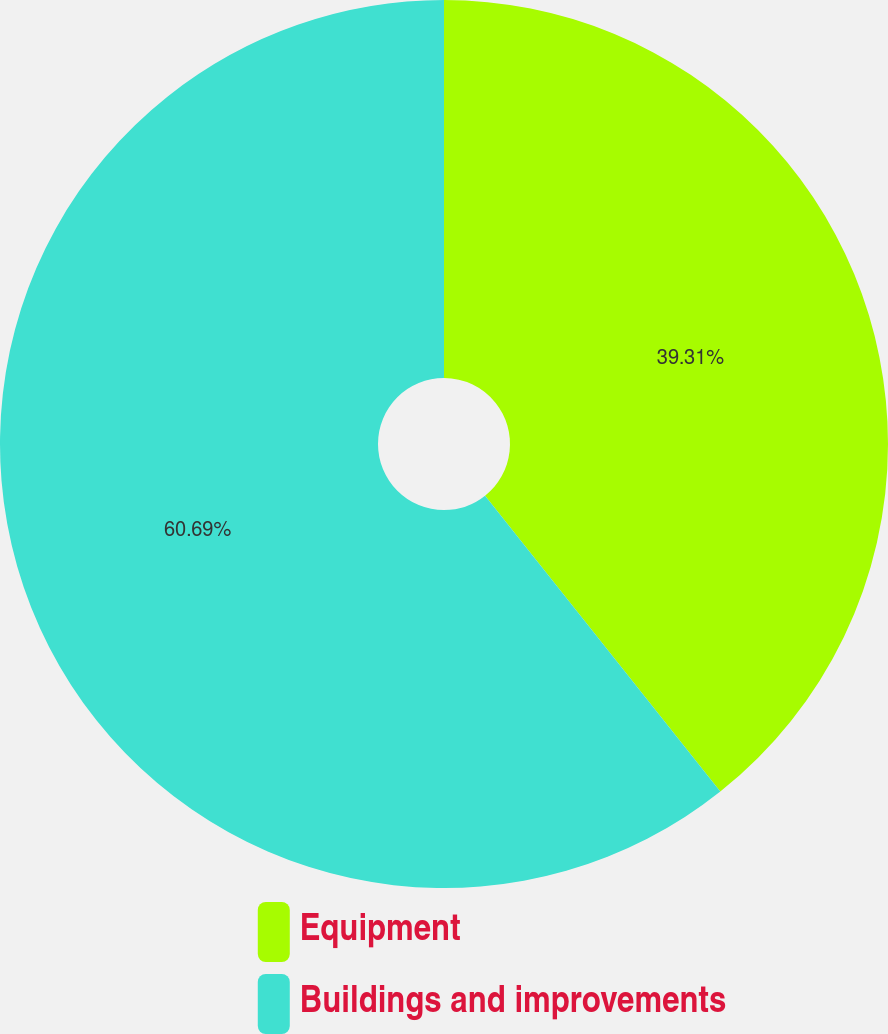Convert chart to OTSL. <chart><loc_0><loc_0><loc_500><loc_500><pie_chart><fcel>Equipment<fcel>Buildings and improvements<nl><fcel>39.31%<fcel>60.69%<nl></chart> 